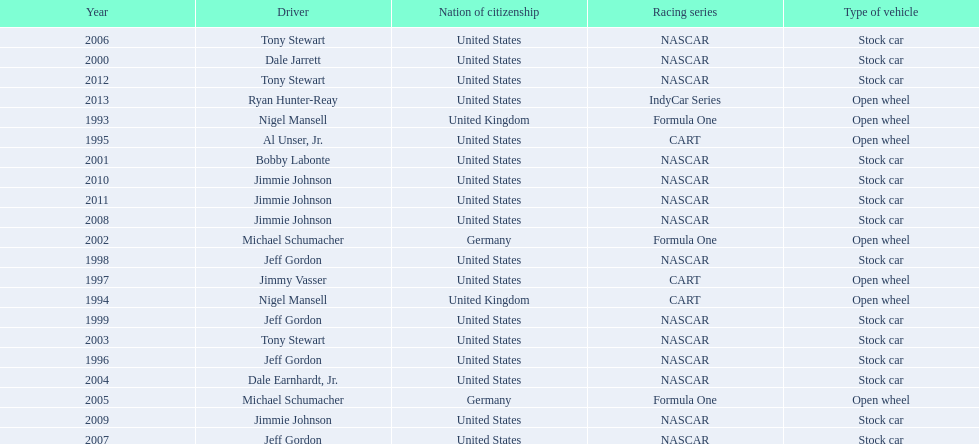What year(s) did nigel mansel receive epsy awards? 1993, 1994. What year(s) did michael schumacher receive epsy awards? 2002, 2005. What year(s) did jeff gordon receive epsy awards? 1996, 1998, 1999, 2007. What year(s) did al unser jr. receive epsy awards? 1995. Which driver only received one epsy award? Al Unser, Jr. 